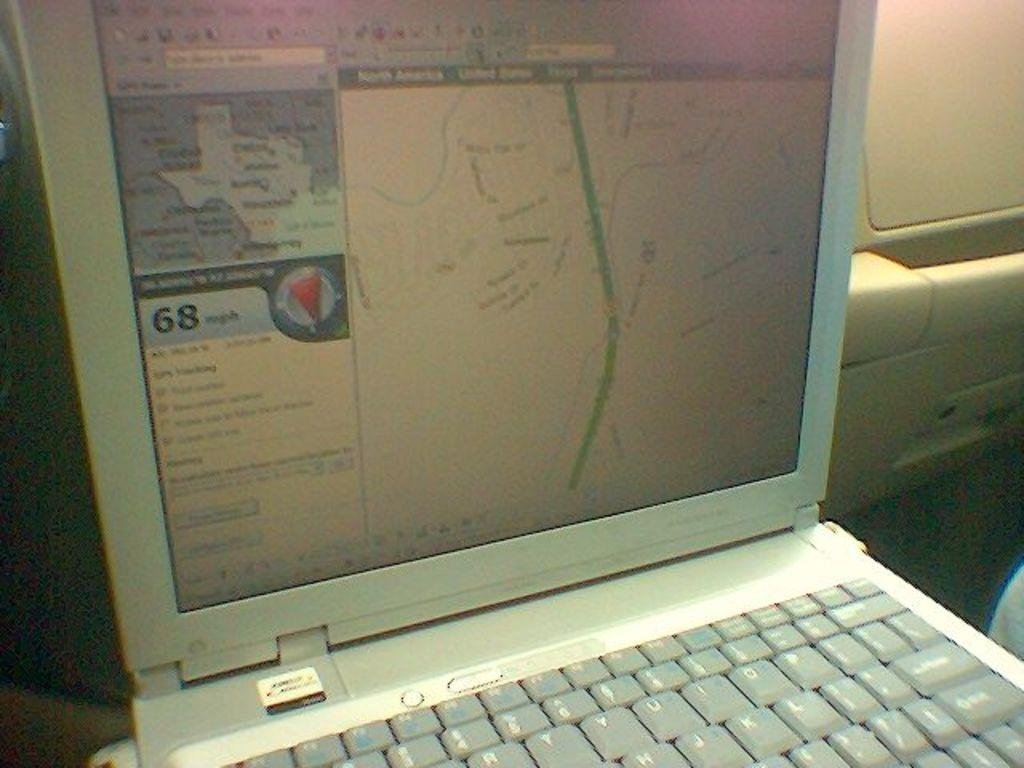<image>
Create a compact narrative representing the image presented. Laptop in a vehicle with a road map of Texas on the screen. 